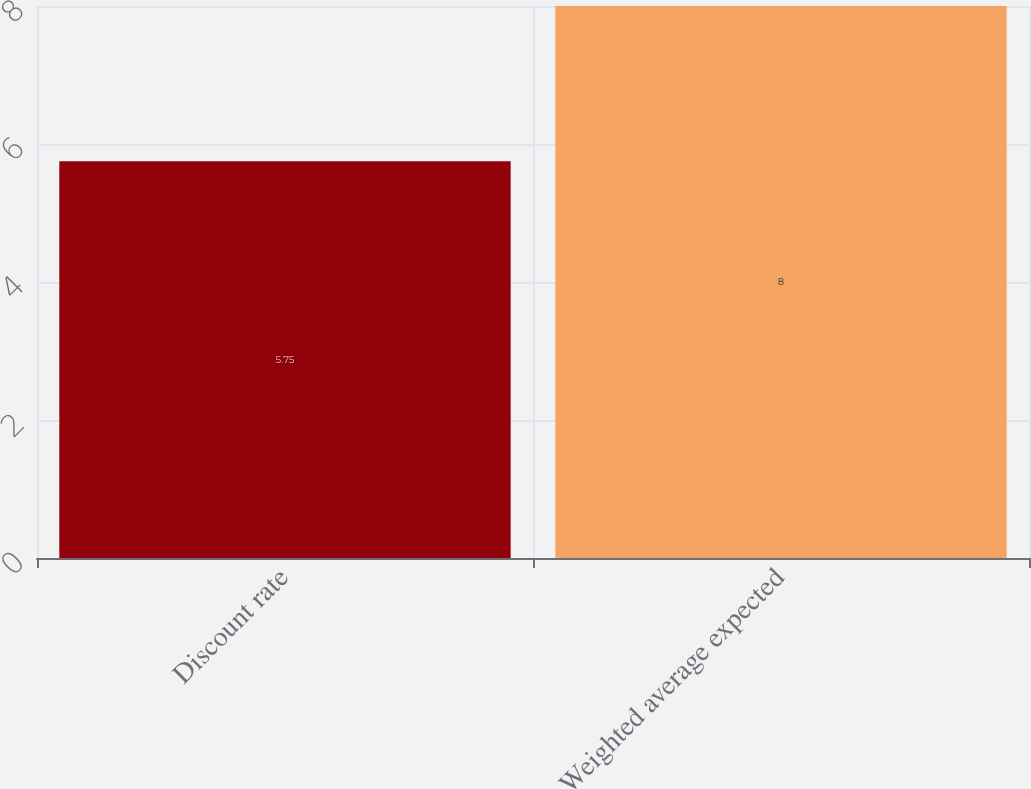<chart> <loc_0><loc_0><loc_500><loc_500><bar_chart><fcel>Discount rate<fcel>Weighted average expected<nl><fcel>5.75<fcel>8<nl></chart> 